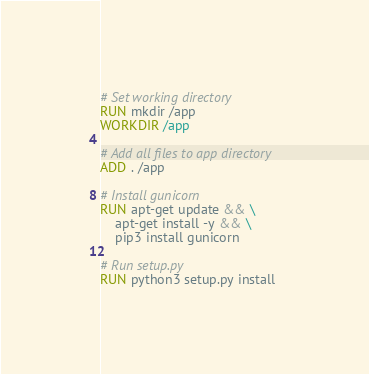Convert code to text. <code><loc_0><loc_0><loc_500><loc_500><_Dockerfile_>
# Set working directory
RUN mkdir /app
WORKDIR /app

# Add all files to app directory
ADD . /app

# Install gunicorn
RUN apt-get update && \
    apt-get install -y && \
    pip3 install gunicorn

# Run setup.py
RUN python3 setup.py install
</code> 